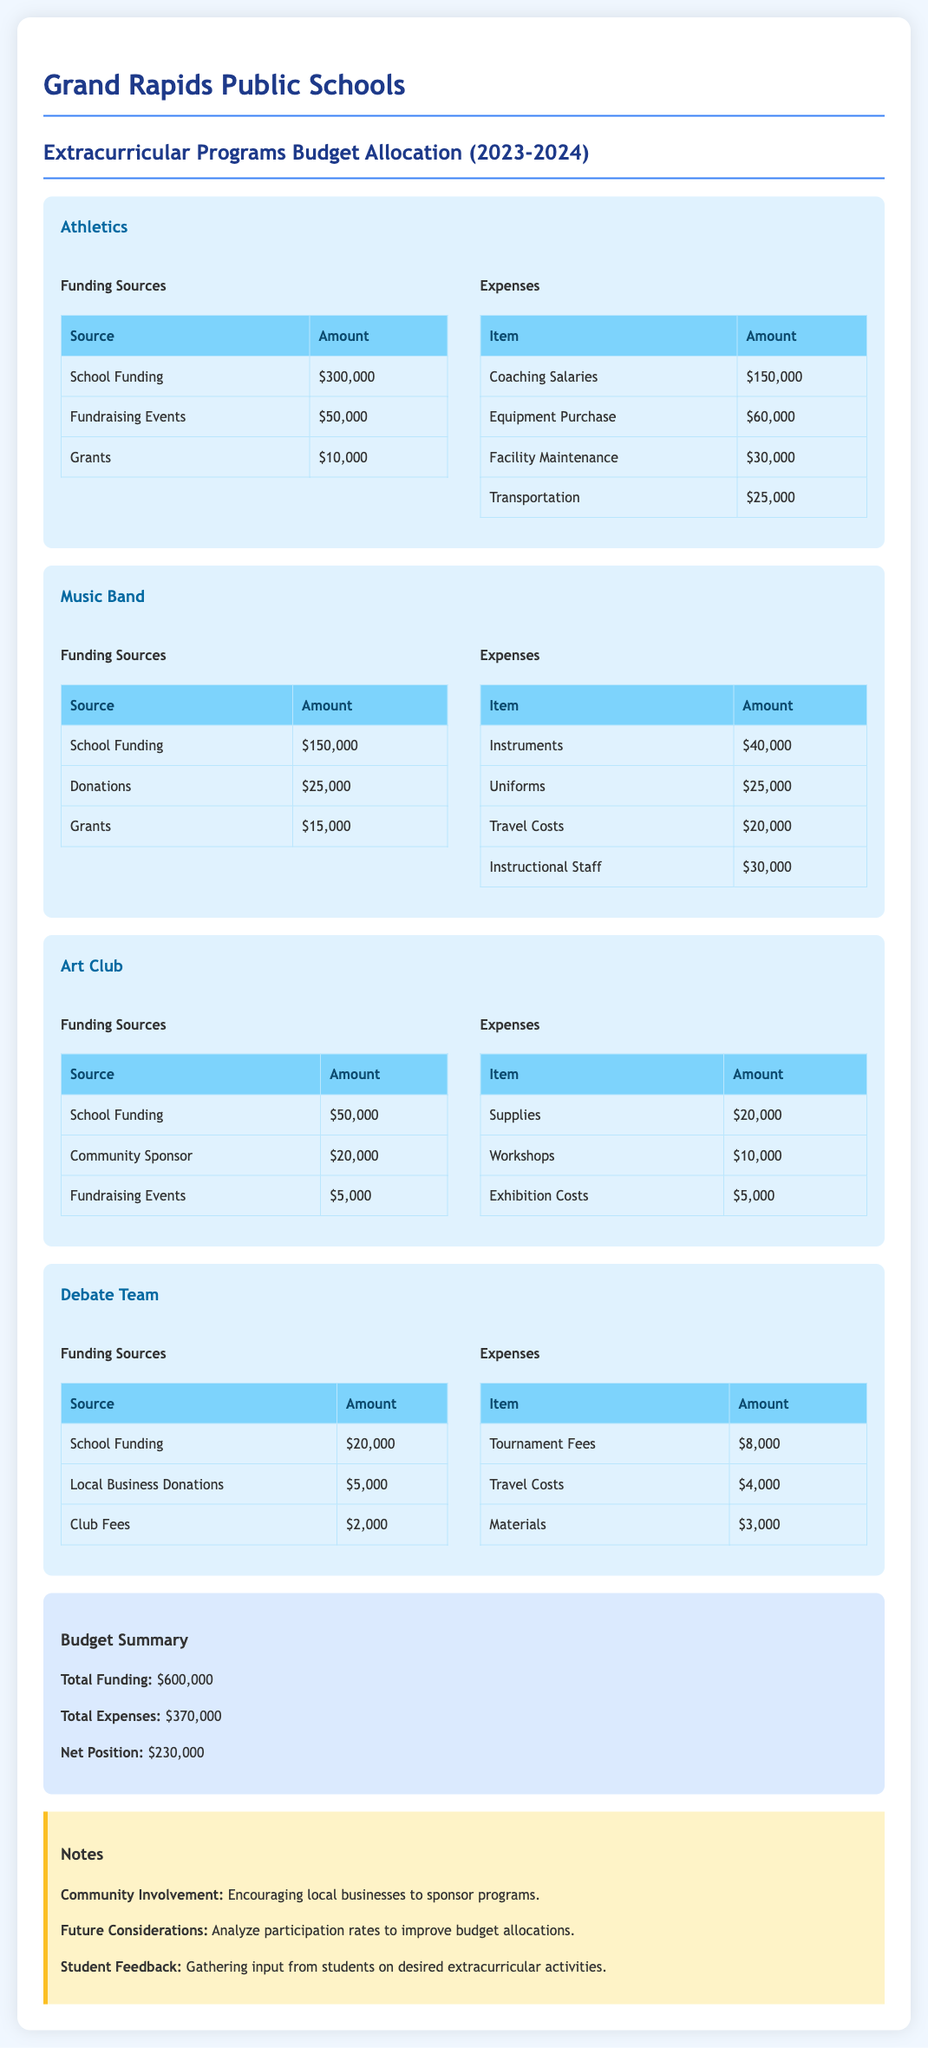what is the total funding for Athletics? The total funding for Athletics is the sum of its funding sources: $300,000 + $50,000 + $10,000 = $360,000.
Answer: $360,000 how much is allocated for Coaching Salaries in Athletics? Coaching Salaries is listed as one of the expenses for Athletics totaling $150,000.
Answer: $150,000 what is the total funding for the Debate Team? The total funding for the Debate Team is the sum of its funding sources: $20,000 + $5,000 + $2,000 = $27,000.
Answer: $27,000 which program has the highest total expenses? Music Band has the highest expenses totaling $115,000 based on its breakdown.
Answer: Music Band what is the net position for the budget? The net position is the difference between total funding and total expenses: $600,000 - $370,000 = $230,000.
Answer: $230,000 how much is provided by Community Sponsors for the Art Club? The funding source from Community Sponsors for the Art Club is $20,000.
Answer: $20,000 what is the total for Travel Costs across all programs? The total for Travel Costs is $25,000 (Athletics) + $20,000 (Music Band) + $4,000 (Debate Team) = $49,000.
Answer: $49,000 which funding source contributes the least to any program? The funding source that contributes the least in the document is Club Fees for the Debate Team, which is $2,000.
Answer: $2,000 what is the total amount spent on Supplies for the Art Club? The amount spent on Supplies for the Art Club is listed as $20,000.
Answer: $20,000 